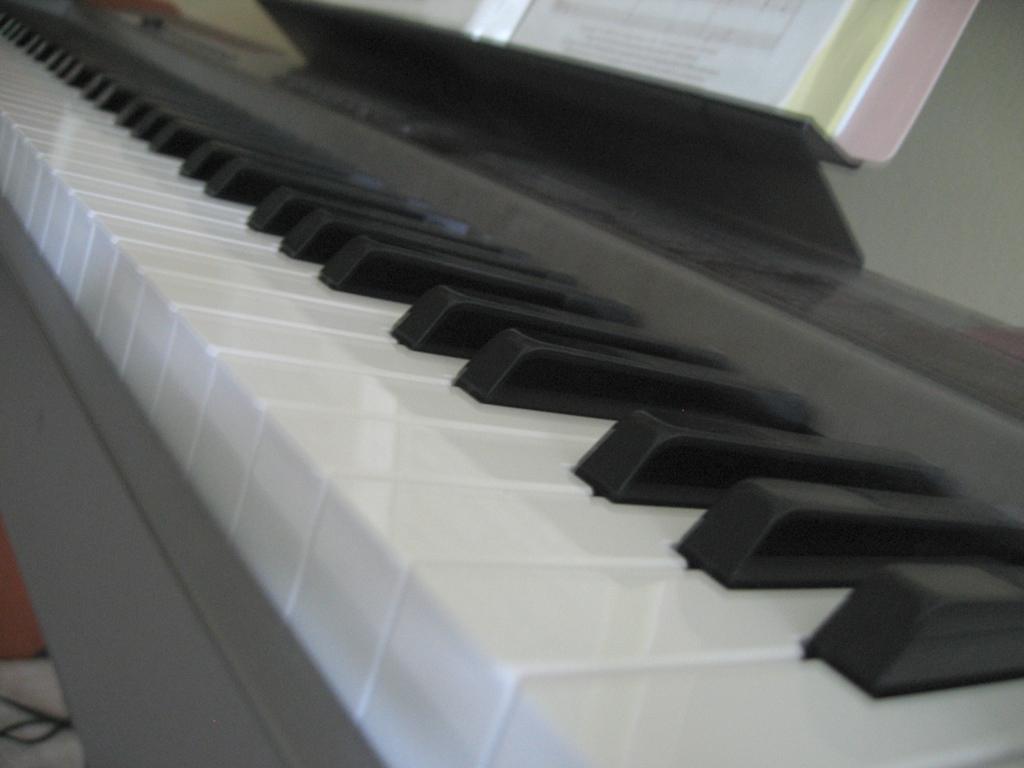Can you describe this image briefly? There is a piano which has a book in front of it. 